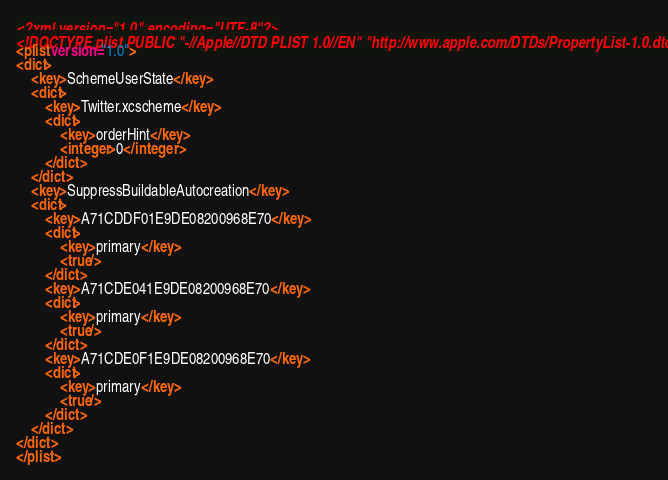<code> <loc_0><loc_0><loc_500><loc_500><_XML_><?xml version="1.0" encoding="UTF-8"?>
<!DOCTYPE plist PUBLIC "-//Apple//DTD PLIST 1.0//EN" "http://www.apple.com/DTDs/PropertyList-1.0.dtd">
<plist version="1.0">
<dict>
	<key>SchemeUserState</key>
	<dict>
		<key>Twitter.xcscheme</key>
		<dict>
			<key>orderHint</key>
			<integer>0</integer>
		</dict>
	</dict>
	<key>SuppressBuildableAutocreation</key>
	<dict>
		<key>A71CDDF01E9DE08200968E70</key>
		<dict>
			<key>primary</key>
			<true/>
		</dict>
		<key>A71CDE041E9DE08200968E70</key>
		<dict>
			<key>primary</key>
			<true/>
		</dict>
		<key>A71CDE0F1E9DE08200968E70</key>
		<dict>
			<key>primary</key>
			<true/>
		</dict>
	</dict>
</dict>
</plist>
</code> 